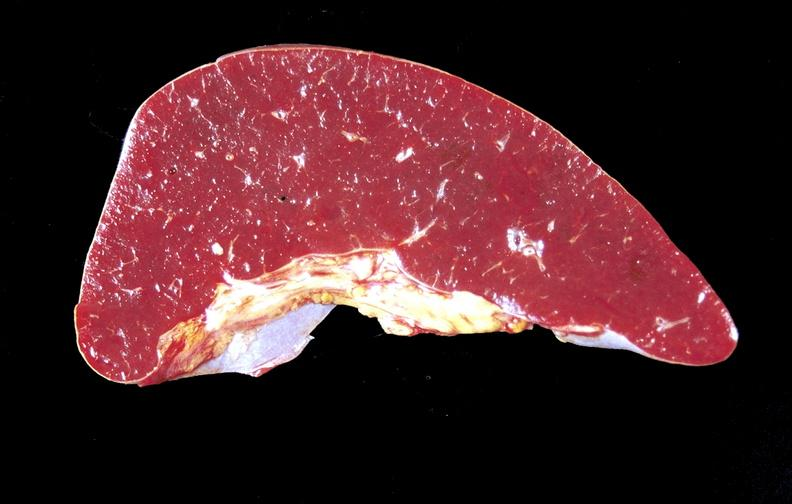where is this part in?
Answer the question using a single word or phrase. Spleen 